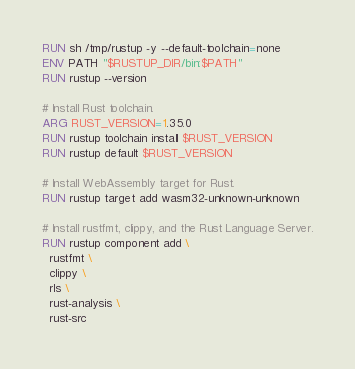Convert code to text. <code><loc_0><loc_0><loc_500><loc_500><_Dockerfile_>RUN sh /tmp/rustup -y --default-toolchain=none
ENV PATH "$RUSTUP_DIR/bin:$PATH"
RUN rustup --version

# Install Rust toolchain.
ARG RUST_VERSION=1.35.0
RUN rustup toolchain install $RUST_VERSION
RUN rustup default $RUST_VERSION

# Install WebAssembly target for Rust.
RUN rustup target add wasm32-unknown-unknown

# Install rustfmt, clippy, and the Rust Language Server.
RUN rustup component add \
  rustfmt \
  clippy \
  rls \
  rust-analysis \
  rust-src
</code> 